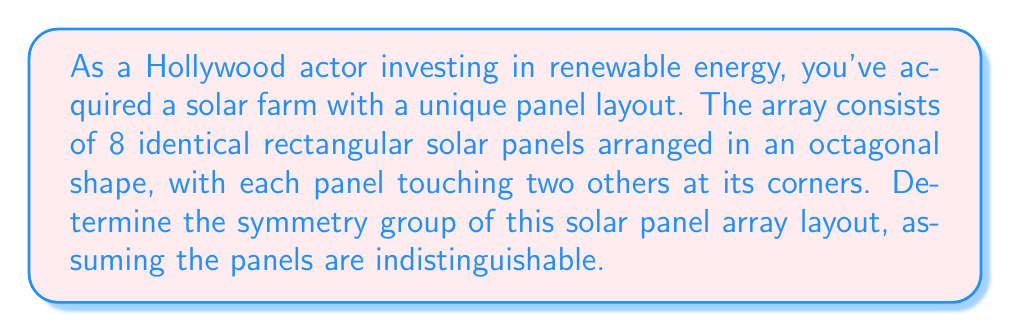What is the answer to this math problem? To determine the symmetry group of this solar panel array, we need to identify all the symmetries that preserve the arrangement. Let's approach this step-by-step:

1. Rotational symmetries:
   The octagonal arrangement has 8-fold rotational symmetry. It can be rotated by multiples of 45° (360°/8) and remain unchanged. This gives us 8 rotational symmetries including the identity rotation.

2. Reflection symmetries:
   There are 8 lines of reflection symmetry in an octagon:
   - 4 passing through opposite vertices
   - 4 passing through the midpoints of opposite sides

3. Group structure:
   These symmetries form the dihedral group $D_8$, which has order 16.

4. Group elements:
   Let $r$ represent a 45° rotation and $s$ represent a reflection.
   The elements of $D_8$ can be written as:
   $$\{e, r, r^2, r^3, r^4, r^5, r^6, r^7, s, sr, sr^2, sr^3, sr^4, sr^5, sr^6, sr^7\}$$
   where $e$ is the identity element.

5. Group properties:
   - Closure: Combining any two symmetries results in another symmetry in the group.
   - Associativity: This is inherent in geometric transformations.
   - Identity: The identity transformation $e$ leaves the array unchanged.
   - Inverse: Each element has an inverse (e.g., $r^{-1} = r^7$, $s^{-1} = s$).

6. Group presentation:
   $D_8$ can be presented as:
   $$\langle r, s \mid r^8 = s^2 = e, srs = r^{-1} \rangle$$

Therefore, the symmetry group of this solar panel array layout is isomorphic to the dihedral group $D_8$.
Answer: The symmetry group of the solar panel array layout is the dihedral group $D_8$ of order 16. 